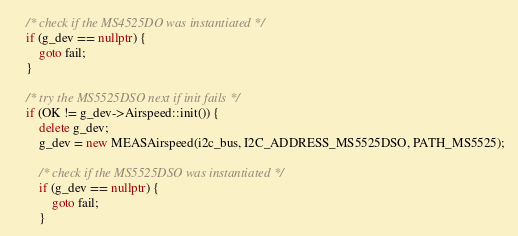<code> <loc_0><loc_0><loc_500><loc_500><_C++_>
	/* check if the MS4525DO was instantiated */
	if (g_dev == nullptr) {
		goto fail;
	}

	/* try the MS5525DSO next if init fails */
	if (OK != g_dev->Airspeed::init()) {
		delete g_dev;
		g_dev = new MEASAirspeed(i2c_bus, I2C_ADDRESS_MS5525DSO, PATH_MS5525);

		/* check if the MS5525DSO was instantiated */
		if (g_dev == nullptr) {
			goto fail;
		}
</code> 